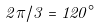Convert formula to latex. <formula><loc_0><loc_0><loc_500><loc_500>2 \pi / 3 = 1 2 0 ^ { \circ }</formula> 